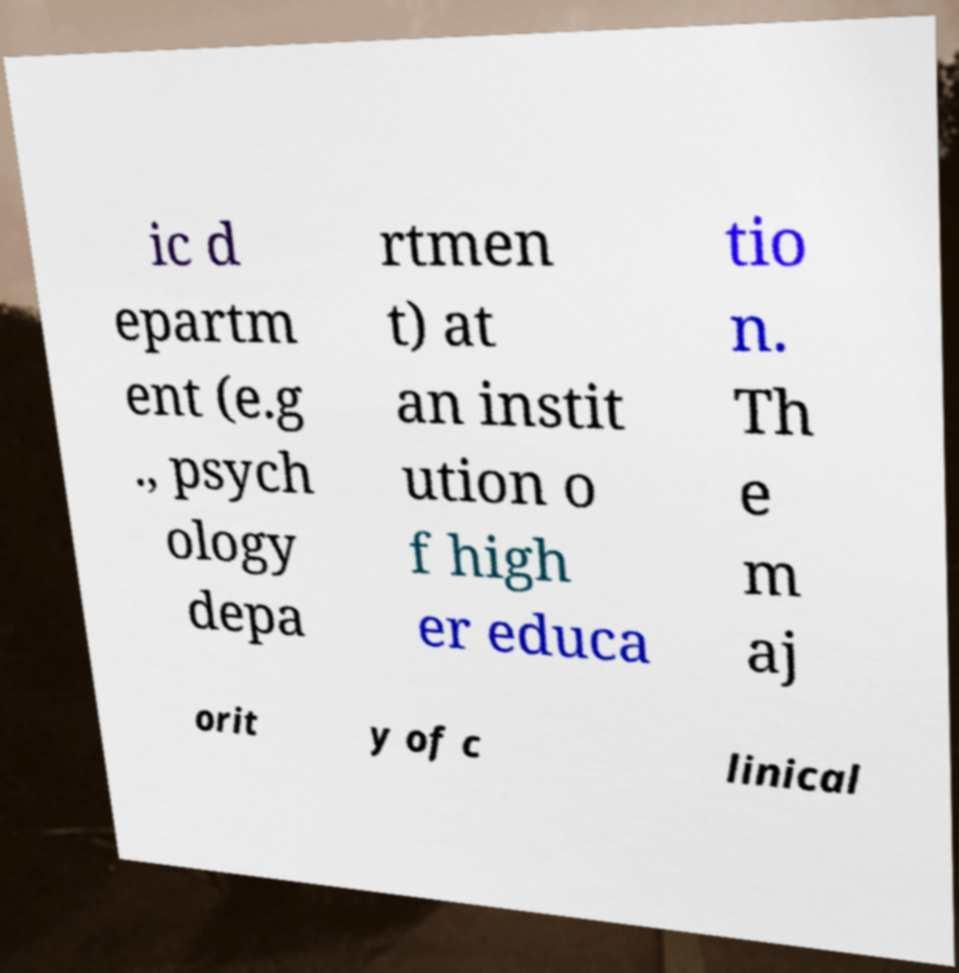Could you extract and type out the text from this image? ic d epartm ent (e.g ., psych ology depa rtmen t) at an instit ution o f high er educa tio n. Th e m aj orit y of c linical 